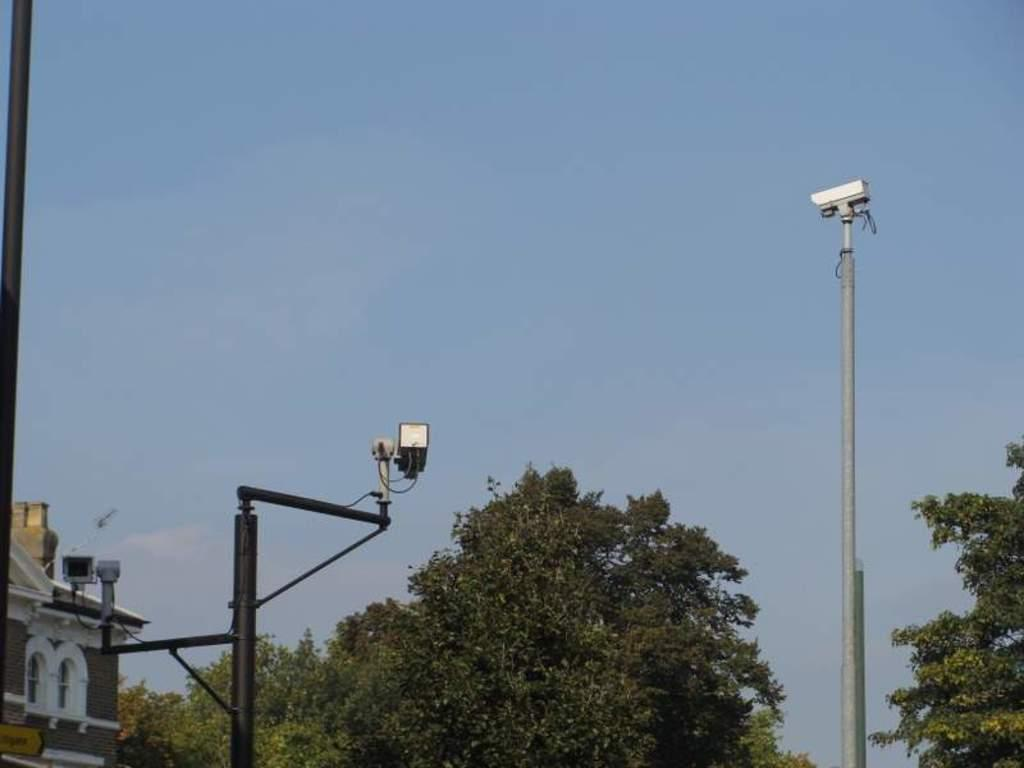What type of structure is present in the image? There is a building in the image. What other objects can be seen in the image? There are light poles, trees, and a camera attached to a pole in the image. What is visible in the background of the image? The sky is visible in the image. Can you see any pets swimming in the lake in the image? There is no lake or pets present in the image. Is there any smoke coming from the building in the image? There is no smoke visible in the image. 